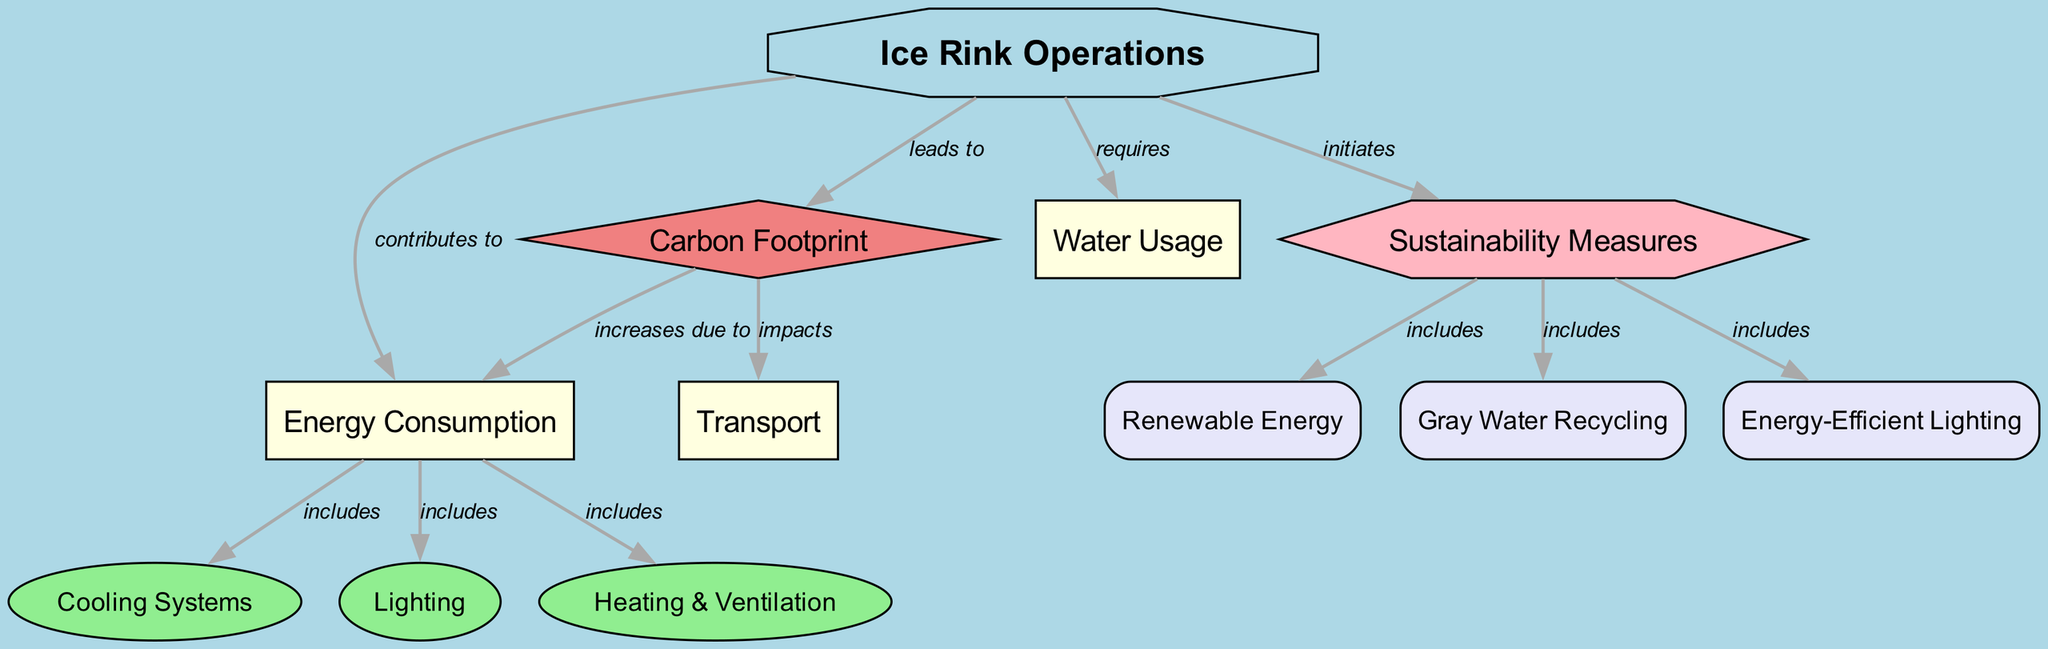What is the main topic of the diagram? The main topic, represented as an octagon in the diagram, is "Ice Rink Operations".
Answer: Ice Rink Operations How many factors are associated with ice rink operations? The diagram shows three factors: "Energy Consumption", "Water Usage", and "Transport". Counting these gives a total of three.
Answer: 3 What type of impact does ice rink operations lead to? The diagram indicates that ice rink operations lead to "Carbon Footprint", represented as a diamond shape, which signifies its impact nature.
Answer: Carbon Footprint What are three subfactors of energy consumption? The diagram lists three subfactors: "Cooling Systems", "Lighting", and "Heating & Ventilation". These are directly linked to energy consumption.
Answer: Cooling Systems, Lighting, Heating & Ventilation What is included in sustainability measures? The three subsolutions included are "Renewable Energy", "Gray Water Recycling", and "Energy-Efficient Lighting". Each contributes to the sustainability initiatives from the ice rink operations.
Answer: Renewable Energy, Gray Water Recycling, Energy-Efficient Lighting How does carbon footprint relate to transport? According to the diagram, carbon footprint impacts transport, shown with an edge connecting the two. This implies a consequence of ice rink operations on transportation activities.
Answer: impacts What is the relationship between energy consumption and carbon footprint? The diagram shows that carbon footprint increases due to energy consumption, indicating a direct effect between these factors.
Answer: increases due to What sustainability measure is related to water usage? The diagram links sustainability measures and introduces "Gray Water Recycling", which is designed to mitigate water usage impacts in operations.
Answer: Gray Water Recycling How does energy consumption affect the carbon footprint? The diagram illustrates that energy consumption increases the carbon footprint. This means that higher energy usage leads to a larger carbon footprint, reflecting an environmental concern.
Answer: increases due to 